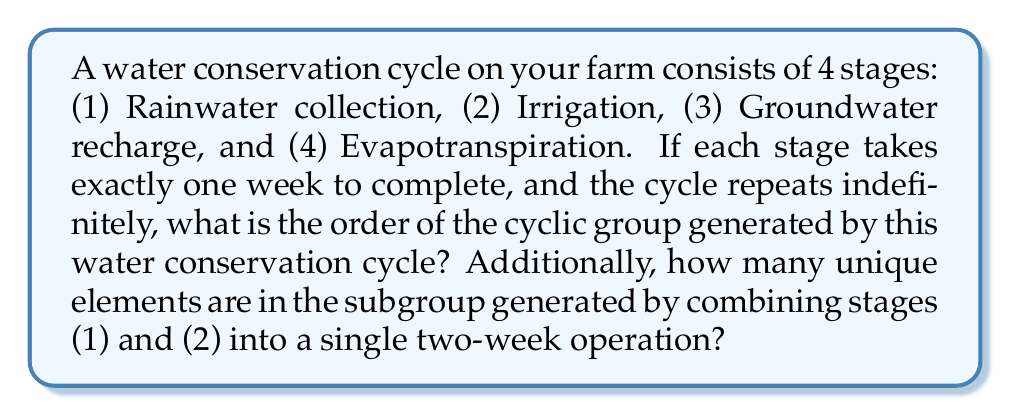Show me your answer to this math problem. Let's approach this step-by-step:

1) First, we need to understand what the cyclic group is in this context:
   - Each complete cycle (all 4 stages) takes 4 weeks to complete.
   - We can represent this as a cyclic group $C_4$ where each element represents a one-week shift in the cycle.

2) The order of a cyclic group is the number of unique elements it contains before repeating. In this case:
   - The cycle repeats after 4 weeks, so the order of the group is 4.

3) Now, let's consider the subgroup generated by combining stages (1) and (2):
   - This combined operation takes 2 weeks to complete.
   - We can represent this as an element $g$ in our group where $g^2 = $ the identity element.

4) To find the number of unique elements in this subgroup:
   - The subgroup will be $\{e, g\}$ where $e$ is the identity element (no shift) and $g$ is the 2-week shift.
   - $g^2 = e$ (the identity), so there are only two unique elements.

5) We can verify this using the Lagrange theorem:
   - The order of a subgroup must divide the order of the main group.
   - The only divisors of 4 are 1, 2, and 4.
   - 2 is the only divisor that matches our subgroup's behavior.

Therefore, the subgroup generated by the combined (1)+(2) operation has 2 unique elements.
Answer: The order of the cyclic group generated by the water conservation cycle is 4. The subgroup generated by combining stages (1) and (2) has 2 unique elements. 